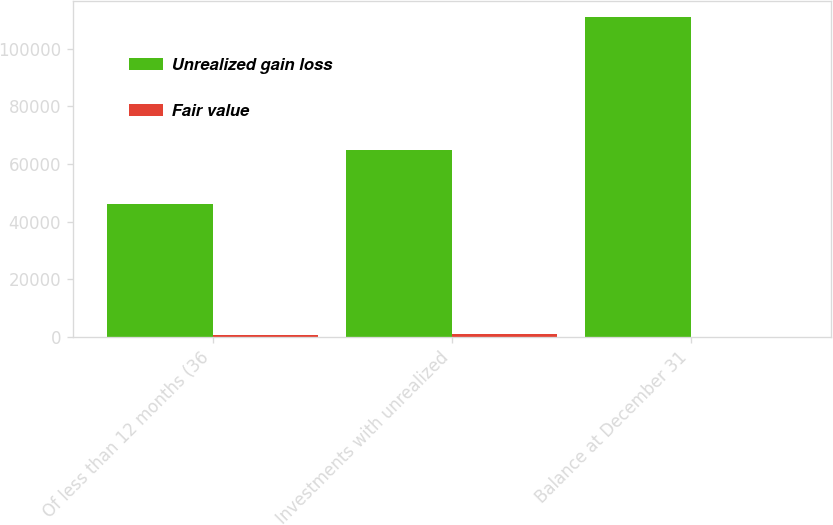Convert chart. <chart><loc_0><loc_0><loc_500><loc_500><stacked_bar_chart><ecel><fcel>Of less than 12 months (36<fcel>Investments with unrealized<fcel>Balance at December 31<nl><fcel>Unrealized gain loss<fcel>46193<fcel>64769<fcel>110962<nl><fcel>Fair value<fcel>824<fcel>964<fcel>140<nl></chart> 